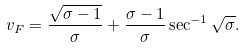<formula> <loc_0><loc_0><loc_500><loc_500>v _ { F } = \frac { \sqrt { \sigma - 1 } } { \sigma } + \frac { \sigma - 1 } { \sigma } \sec ^ { - 1 } \sqrt { \sigma } .</formula> 